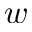Convert formula to latex. <formula><loc_0><loc_0><loc_500><loc_500>w</formula> 